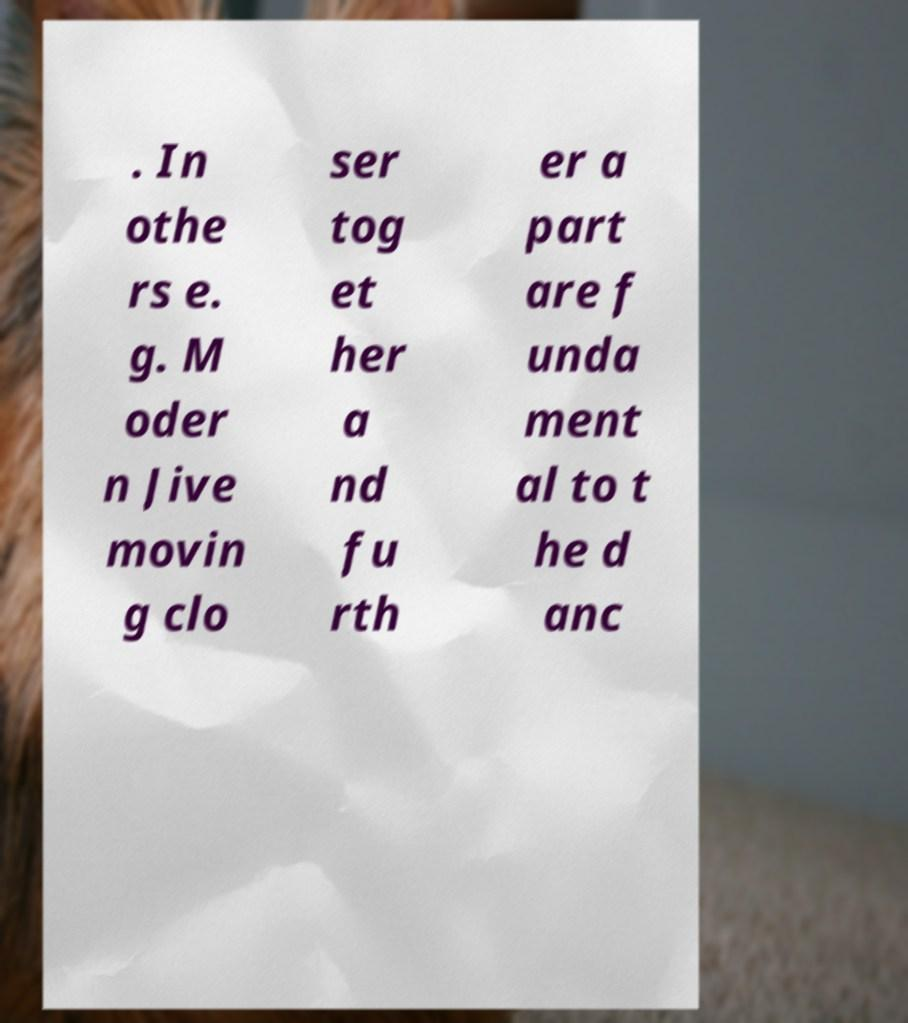What messages or text are displayed in this image? I need them in a readable, typed format. . In othe rs e. g. M oder n Jive movin g clo ser tog et her a nd fu rth er a part are f unda ment al to t he d anc 